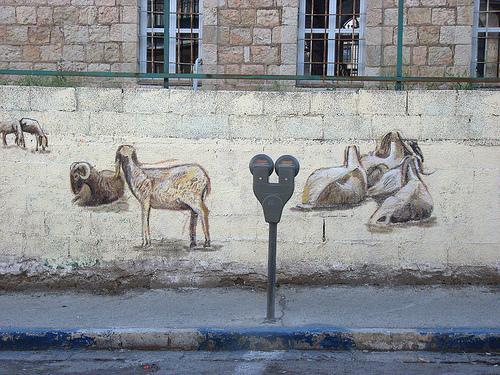Describe an instance of weathering or wear in the image. Peeling blue paint on the curb demonstrates wear and weathering, as the paint has deteriorated over time due to natural elements and exposure to the environment. List some different types of objects found in the image. Some objects found in the image include murals of animals, a parking meter, a green pole, a standard brick wall, a sidewalk, windows with metal bars, and blue paint on the sidewalk. What is the main object of interest on this image and describe its appearance? The main object of interest in this image is a series of murals depicting animals such as goats and rams, painted on a dingy beige-colored brick wall. Choose one descriptive part of the scene, explain what it is, and why it's interesting. A mural of a group of goats painted on a wall grabs attention because of its vivid depiction, skillful artwork, and placement on an otherwise beige-colored brick wall. This adds a touch of creativity and visual interest to the scene. Identify the primary color of the paint on the sidewalk and what it might signify. The primary color of the paint on the sidewalk is blue. It might signify a marked parking zone or a designated pedestrian pathway. Which object in the image can be considered damaged and how? The crack in the sidewalk can be considered damaged. It is a flaw in the pavement, likely caused by wear and tear, weather conditions, or ground shifting. Describe the purpose of one object in the image and its characteristics. The parking meter's purpose is to collect payment for short-term parking. It is a black metal, dual parking meter placed on the sidewalk, utilized for parking control. Mention an object in the image with an interesting texture and describe it. A red brick wall has an interesting texture, as it's comprised of red square bricks with visible cracks that give it a rustic and aged appearance. Choose a scene from the image and imagine how it might be used in a product advertisement. The murals of goats, rams, and other animals on the wall could be used in an advertisement for a creative art studio, showcasing impressive painting skills and the ability to create unique and engaging artwork for public spaces. Select two objects in close proximity and describe their relationship. A black metal parking meter stands on the sidewalk, while the blue paint on the sidewalk surrounds it. These two objects share the same location, with the blue paint defining a specific area of the sidewalk and enhancing its visual appeal. 